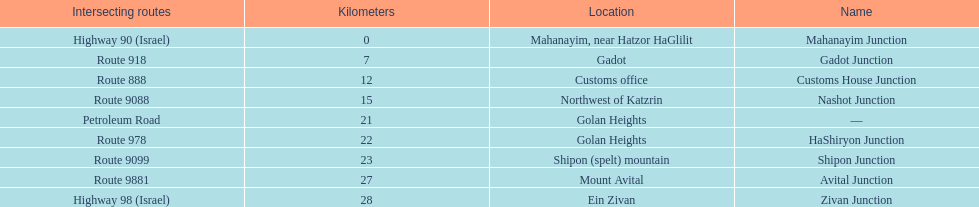What is the last junction on highway 91? Zivan Junction. 